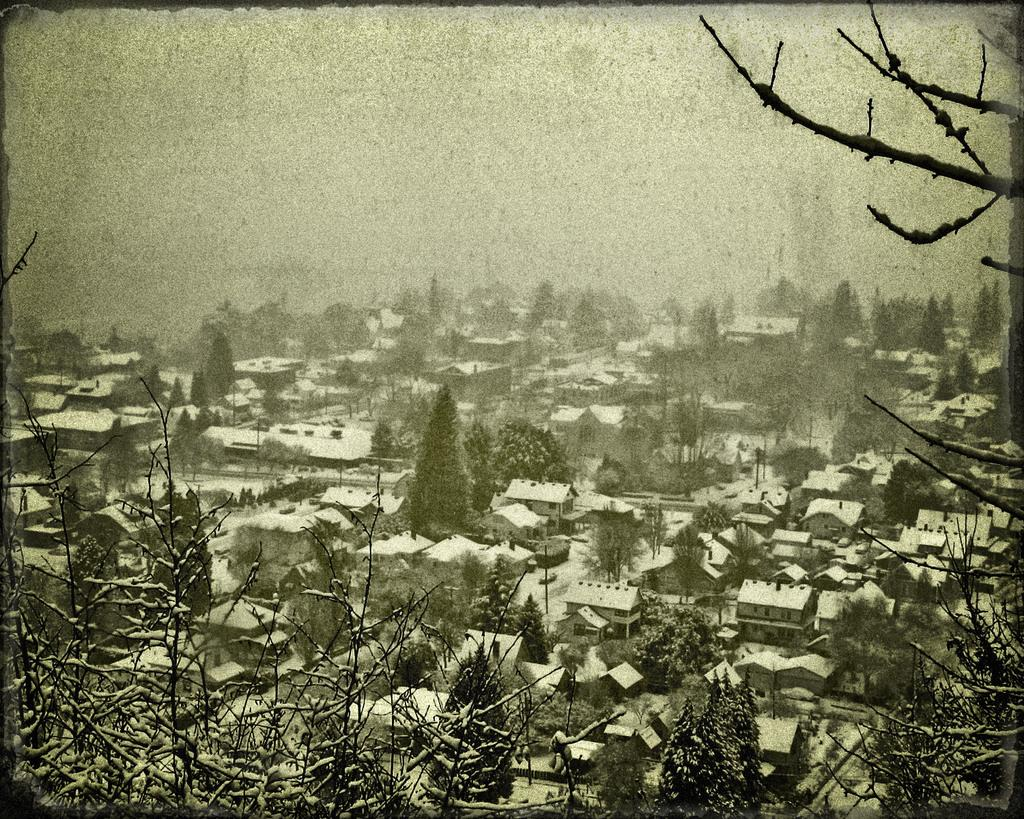What type of natural elements can be seen in the image? There are trees in the image. What type of man-made structures are present in the image? There are buildings in the image. What is visible at the top of the image? The sky is visible at the top of the image. What historical event is depicted in the image? There is no historical event depicted in the image; it features trees, buildings, and the sky. How many times does the lift go up and down in the image? There is no lift present in the image, so it cannot be determined how many times it goes up and down. 